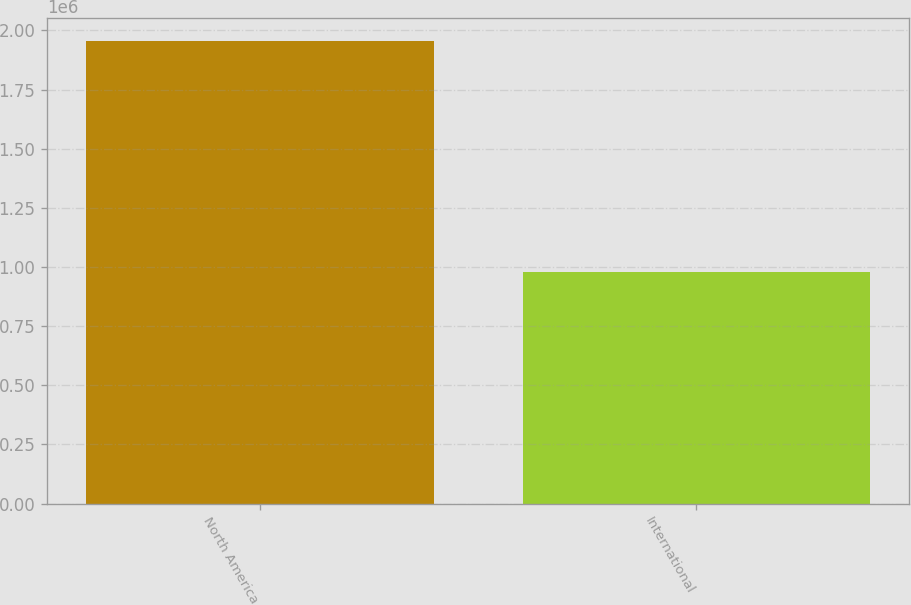<chart> <loc_0><loc_0><loc_500><loc_500><bar_chart><fcel>North America<fcel>International<nl><fcel>1.95603e+06<fcel>977128<nl></chart> 